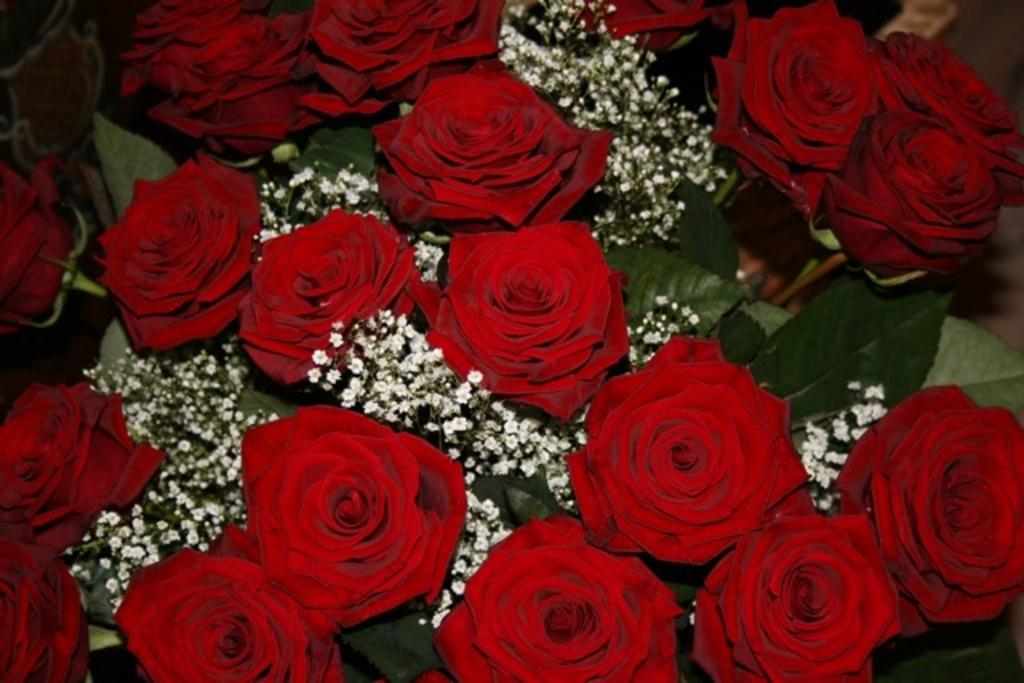What type of flowers are in the image? There are red roses in the image. What color are the leaves associated with the flowers? There are green leaves in the image. Can you describe any other items visible in the image? There are other items in the image, but their specific details are not mentioned in the provided facts. What type of pain is the person experiencing while sitting on the chair in the image? There is no person or chair present in the image, so it is not possible to determine if someone is experiencing pain or not. 